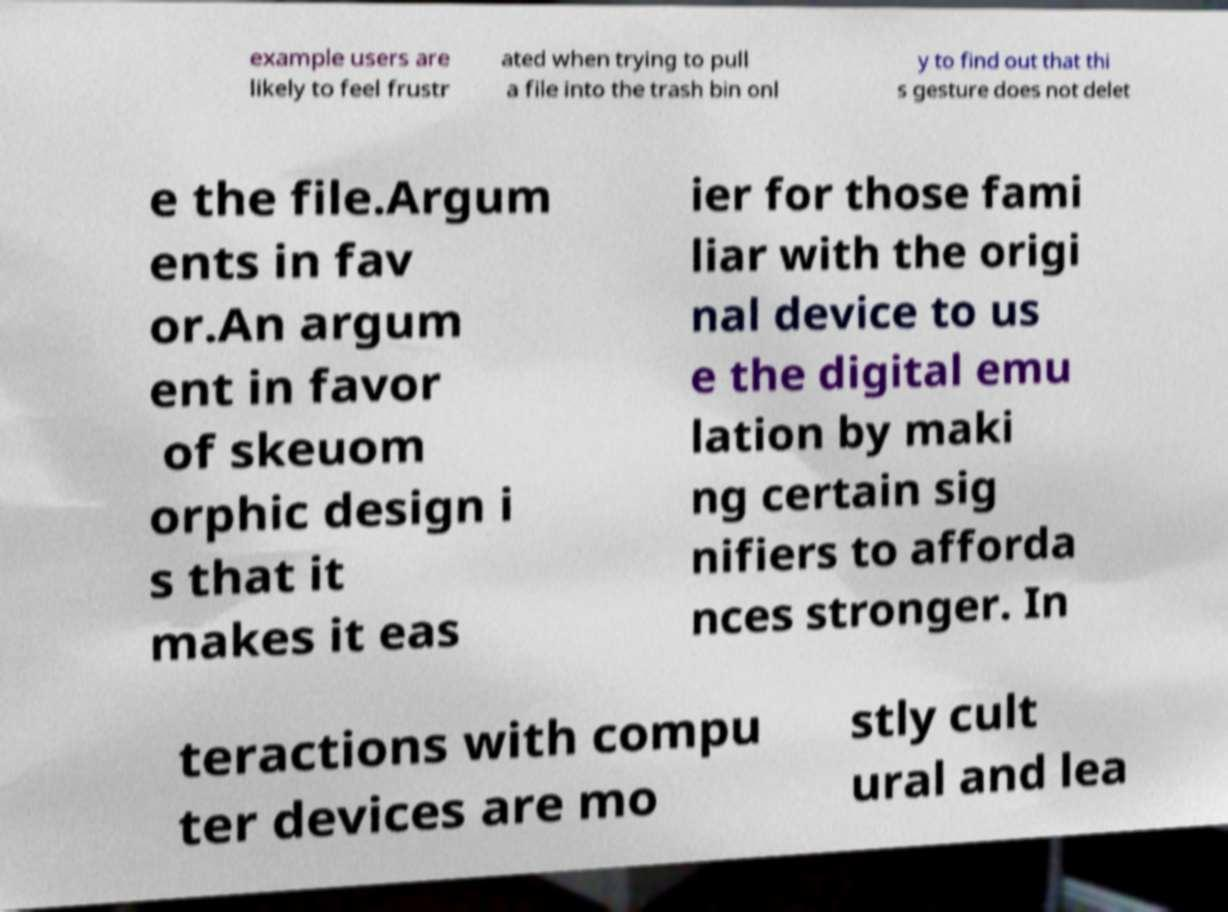Could you assist in decoding the text presented in this image and type it out clearly? example users are likely to feel frustr ated when trying to pull a file into the trash bin onl y to find out that thi s gesture does not delet e the file.Argum ents in fav or.An argum ent in favor of skeuom orphic design i s that it makes it eas ier for those fami liar with the origi nal device to us e the digital emu lation by maki ng certain sig nifiers to afforda nces stronger. In teractions with compu ter devices are mo stly cult ural and lea 